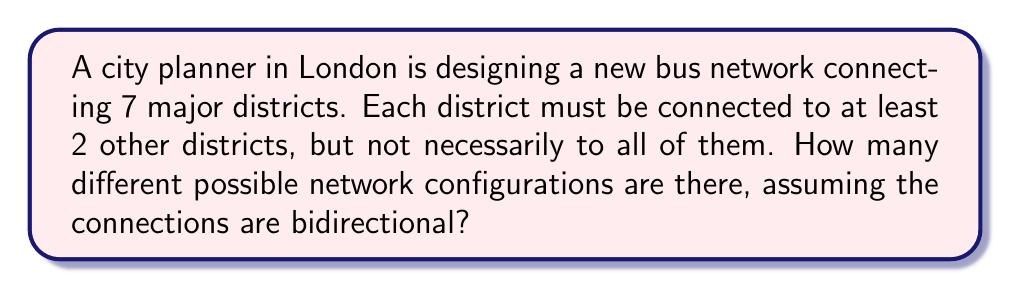Help me with this question. Let's approach this step-by-step:

1) First, we need to understand what we're counting. We're looking at all possible ways to connect 7 districts, where each district has at least 2 connections.

2) This problem can be solved using graph theory. Each district is a vertex, and each connection is an edge.

3) The total number of possible edges in a graph with 7 vertices is:
   
   $$\binom{7}{2} = \frac{7!}{2!(7-2)!} = \frac{7 \cdot 6}{2} = 21$$

4) Now, we need to consider all possible combinations of these 21 edges, excluding those where any vertex has fewer than 2 edges.

5) The total number of possible combinations of edges is $2^{21}$, as each edge can either be present or absent.

6) However, we need to subtract the invalid configurations. These are:
   - Configurations with 0 or 1 edge: $\binom{21}{0} + \binom{21}{1} = 1 + 21 = 22$
   - Configurations where at least one vertex has fewer than 2 edges

7) Calculating the number of configurations where at least one vertex has fewer than 2 edges is complex. We can use the Principle of Inclusion-Exclusion:

   $$\sum_{i=1}^7 \binom{7}{i} \cdot (2^{\binom{7-i}{2}} - \binom{21-\binom{i}{2}}{0} - \binom{21-\binom{i}{2}}{1})$$

8) This formula counts the number of ways to choose i vertices with fewer than 2 edges, and then counts the valid configurations for the remaining vertices, subtracting configurations with 0 or 1 edge.

9) Calculating this:
   
   $$\binom{7}{1} \cdot (2^{15} - 1 - 15) + \binom{7}{2} \cdot (2^{10} - 1 - 10) + ... + \binom{7}{7} \cdot (2^0 - 1 - 0) = 2,097,152$$

10) Therefore, the total number of valid configurations is:

    $$2^{21} - 22 - 2,097,152 = 2,097,152 - 22 - 2,097,152 = 2,097,130$$
Answer: The number of different possible network configurations is 2,097,130. 